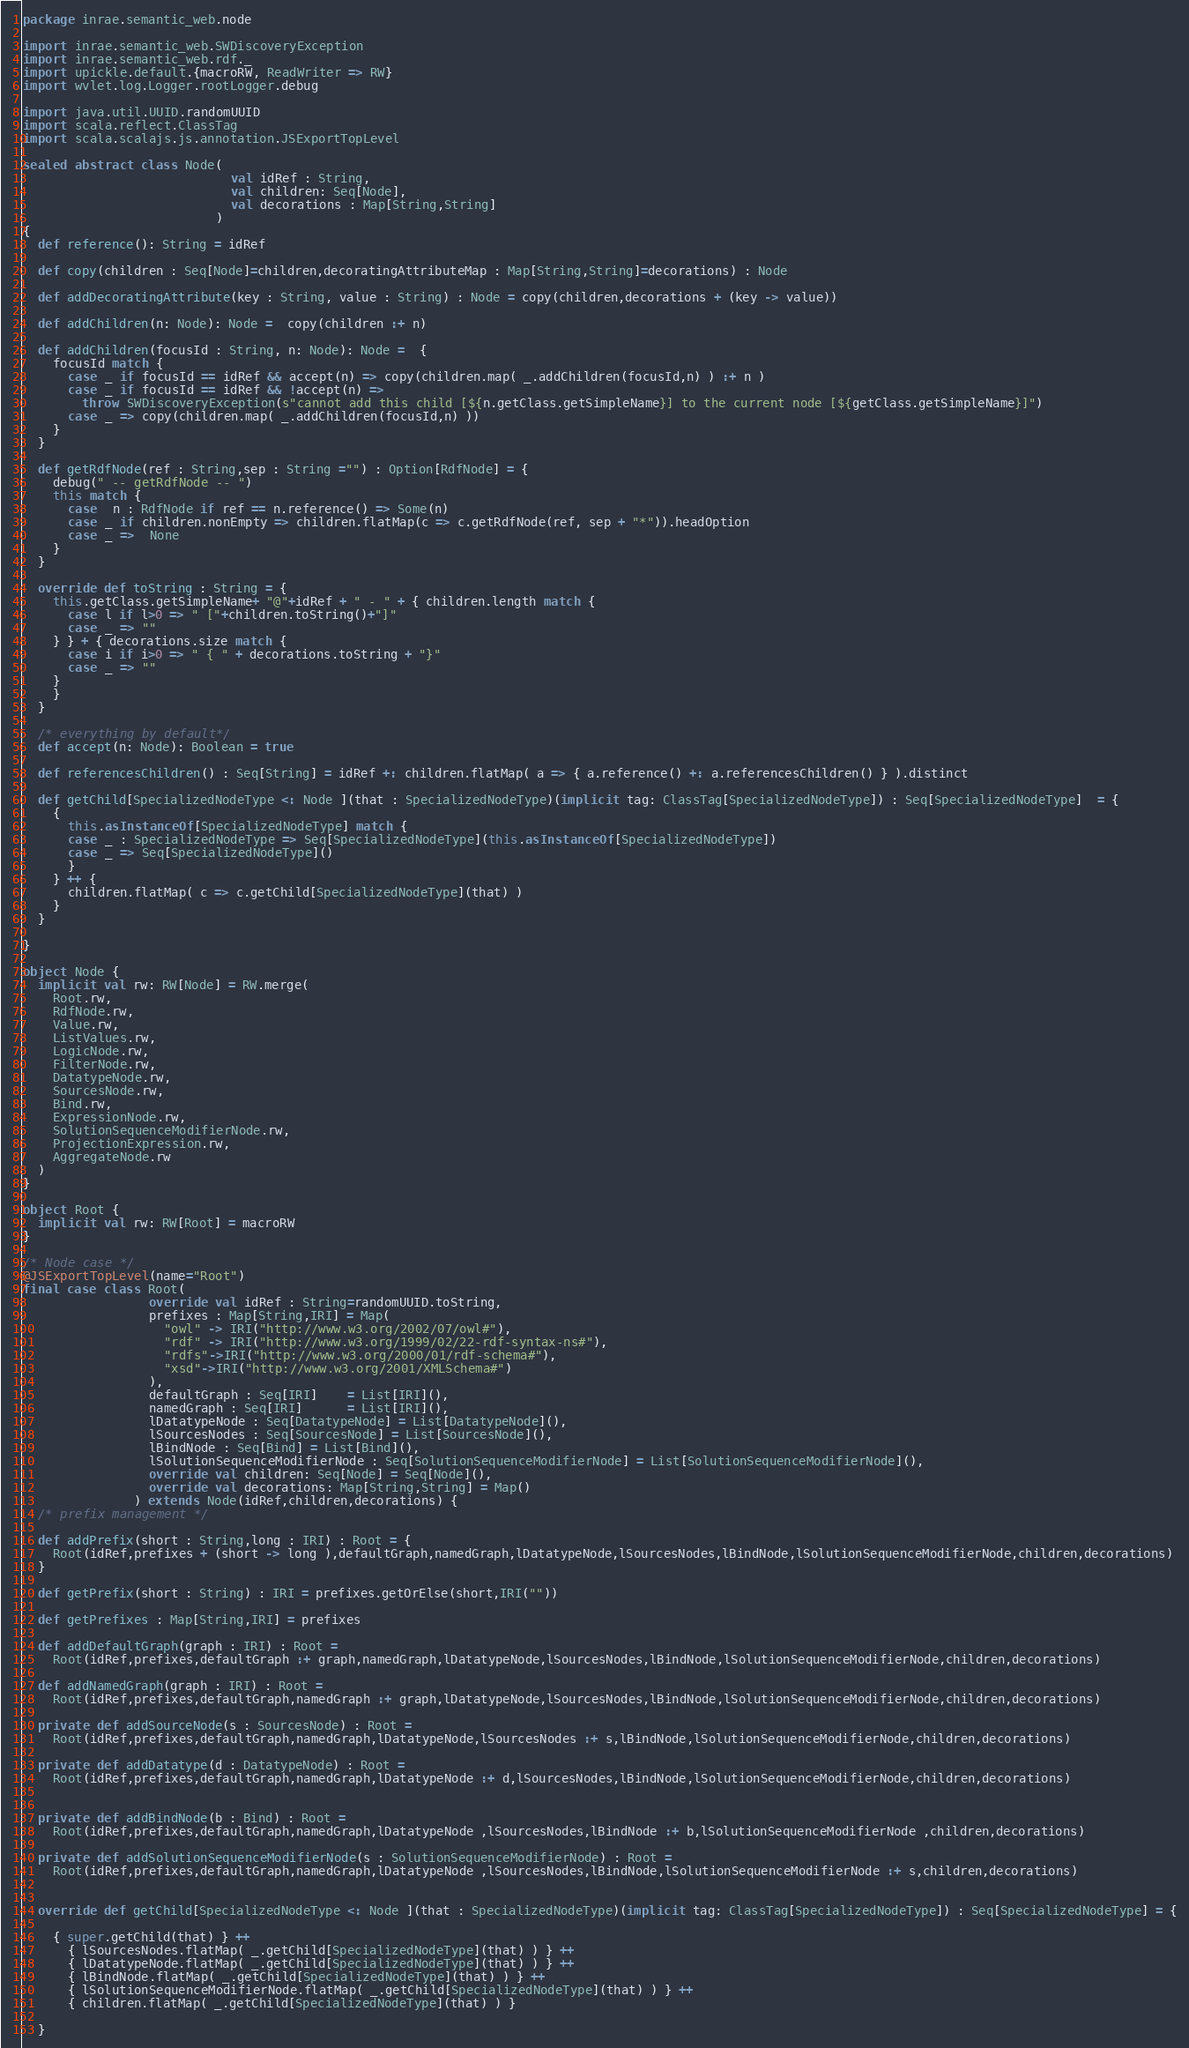<code> <loc_0><loc_0><loc_500><loc_500><_Scala_>package inrae.semantic_web.node

import inrae.semantic_web.SWDiscoveryException
import inrae.semantic_web.rdf._
import upickle.default.{macroRW, ReadWriter => RW}
import wvlet.log.Logger.rootLogger.debug

import java.util.UUID.randomUUID
import scala.reflect.ClassTag
import scala.scalajs.js.annotation.JSExportTopLevel

sealed abstract class Node(
                            val idRef : String,
                            val children: Seq[Node],
                            val decorations : Map[String,String]
                          )
{
  def reference(): String = idRef

  def copy(children : Seq[Node]=children,decoratingAttributeMap : Map[String,String]=decorations) : Node

  def addDecoratingAttribute(key : String, value : String) : Node = copy(children,decorations + (key -> value))

  def addChildren(n: Node): Node =  copy(children :+ n)

  def addChildren(focusId : String, n: Node): Node =  {
    focusId match {
      case _ if focusId == idRef && accept(n) => copy(children.map( _.addChildren(focusId,n) ) :+ n )
      case _ if focusId == idRef && !accept(n) =>
        throw SWDiscoveryException(s"cannot add this child [${n.getClass.getSimpleName}] to the current node [${getClass.getSimpleName}]")
      case _ => copy(children.map( _.addChildren(focusId,n) ))
    }
  }

  def getRdfNode(ref : String,sep : String ="") : Option[RdfNode] = {
    debug(" -- getRdfNode -- ")
    this match {
      case  n : RdfNode if ref == n.reference() => Some(n)
      case _ if children.nonEmpty => children.flatMap(c => c.getRdfNode(ref, sep + "*")).headOption
      case _ =>  None
    }
  }

  override def toString : String = {
    this.getClass.getSimpleName+ "@"+idRef + " - " + { children.length match {
      case l if l>0 => " ["+children.toString()+"]"
      case _ => ""
    } } + { decorations.size match {
      case i if i>0 => " { " + decorations.toString + "}"
      case _ => ""
    }
    }
  }

  /* everything by default*/
  def accept(n: Node): Boolean = true

  def referencesChildren() : Seq[String] = idRef +: children.flatMap( a => { a.reference() +: a.referencesChildren() } ).distinct

  def getChild[SpecializedNodeType <: Node ](that : SpecializedNodeType)(implicit tag: ClassTag[SpecializedNodeType]) : Seq[SpecializedNodeType]  = {
    {
      this.asInstanceOf[SpecializedNodeType] match {
      case _ : SpecializedNodeType => Seq[SpecializedNodeType](this.asInstanceOf[SpecializedNodeType])
      case _ => Seq[SpecializedNodeType]()
      }
    } ++ {
      children.flatMap( c => c.getChild[SpecializedNodeType](that) )
    }
  }

}

object Node {
  implicit val rw: RW[Node] = RW.merge(
    Root.rw,
    RdfNode.rw,
    Value.rw,
    ListValues.rw,
    LogicNode.rw,
    FilterNode.rw,
    DatatypeNode.rw,
    SourcesNode.rw,
    Bind.rw,
    ExpressionNode.rw,
    SolutionSequenceModifierNode.rw,
    ProjectionExpression.rw,
    AggregateNode.rw
  )
}

object Root {
  implicit val rw: RW[Root] = macroRW
}

/* Node case */
@JSExportTopLevel(name="Root")
final case class Root(
                 override val idRef : String=randomUUID.toString,
                 prefixes : Map[String,IRI] = Map(
                   "owl" -> IRI("http://www.w3.org/2002/07/owl#"),
                   "rdf" -> IRI("http://www.w3.org/1999/02/22-rdf-syntax-ns#"),
                   "rdfs"->IRI("http://www.w3.org/2000/01/rdf-schema#"),
                   "xsd"->IRI("http://www.w3.org/2001/XMLSchema#")
                 ),
                 defaultGraph : Seq[IRI]    = List[IRI](),
                 namedGraph : Seq[IRI]      = List[IRI](),
                 lDatatypeNode : Seq[DatatypeNode] = List[DatatypeNode](),
                 lSourcesNodes : Seq[SourcesNode] = List[SourcesNode](),
                 lBindNode : Seq[Bind] = List[Bind](),
                 lSolutionSequenceModifierNode : Seq[SolutionSequenceModifierNode] = List[SolutionSequenceModifierNode](),
                 override val children: Seq[Node] = Seq[Node](),
                 override val decorations: Map[String,String] = Map()
               ) extends Node(idRef,children,decorations) {
  /* prefix management */

  def addPrefix(short : String,long : IRI) : Root = {
    Root(idRef,prefixes + (short -> long ),defaultGraph,namedGraph,lDatatypeNode,lSourcesNodes,lBindNode,lSolutionSequenceModifierNode,children,decorations)
  }

  def getPrefix(short : String) : IRI = prefixes.getOrElse(short,IRI(""))

  def getPrefixes : Map[String,IRI] = prefixes

  def addDefaultGraph(graph : IRI) : Root =
    Root(idRef,prefixes,defaultGraph :+ graph,namedGraph,lDatatypeNode,lSourcesNodes,lBindNode,lSolutionSequenceModifierNode,children,decorations)

  def addNamedGraph(graph : IRI) : Root =
    Root(idRef,prefixes,defaultGraph,namedGraph :+ graph,lDatatypeNode,lSourcesNodes,lBindNode,lSolutionSequenceModifierNode,children,decorations)

  private def addSourceNode(s : SourcesNode) : Root =
    Root(idRef,prefixes,defaultGraph,namedGraph,lDatatypeNode,lSourcesNodes :+ s,lBindNode,lSolutionSequenceModifierNode,children,decorations)

  private def addDatatype(d : DatatypeNode) : Root =
    Root(idRef,prefixes,defaultGraph,namedGraph,lDatatypeNode :+ d,lSourcesNodes,lBindNode,lSolutionSequenceModifierNode,children,decorations)


  private def addBindNode(b : Bind) : Root =
    Root(idRef,prefixes,defaultGraph,namedGraph,lDatatypeNode ,lSourcesNodes,lBindNode :+ b,lSolutionSequenceModifierNode ,children,decorations)

  private def addSolutionSequenceModifierNode(s : SolutionSequenceModifierNode) : Root =
    Root(idRef,prefixes,defaultGraph,namedGraph,lDatatypeNode ,lSourcesNodes,lBindNode,lSolutionSequenceModifierNode :+ s,children,decorations)


  override def getChild[SpecializedNodeType <: Node ](that : SpecializedNodeType)(implicit tag: ClassTag[SpecializedNodeType]) : Seq[SpecializedNodeType] = {

    { super.getChild(that) } ++
      { lSourcesNodes.flatMap( _.getChild[SpecializedNodeType](that) ) } ++
      { lDatatypeNode.flatMap( _.getChild[SpecializedNodeType](that) ) } ++
      { lBindNode.flatMap( _.getChild[SpecializedNodeType](that) ) } ++
      { lSolutionSequenceModifierNode.flatMap( _.getChild[SpecializedNodeType](that) ) } ++
      { children.flatMap( _.getChild[SpecializedNodeType](that) ) }

  }
</code> 